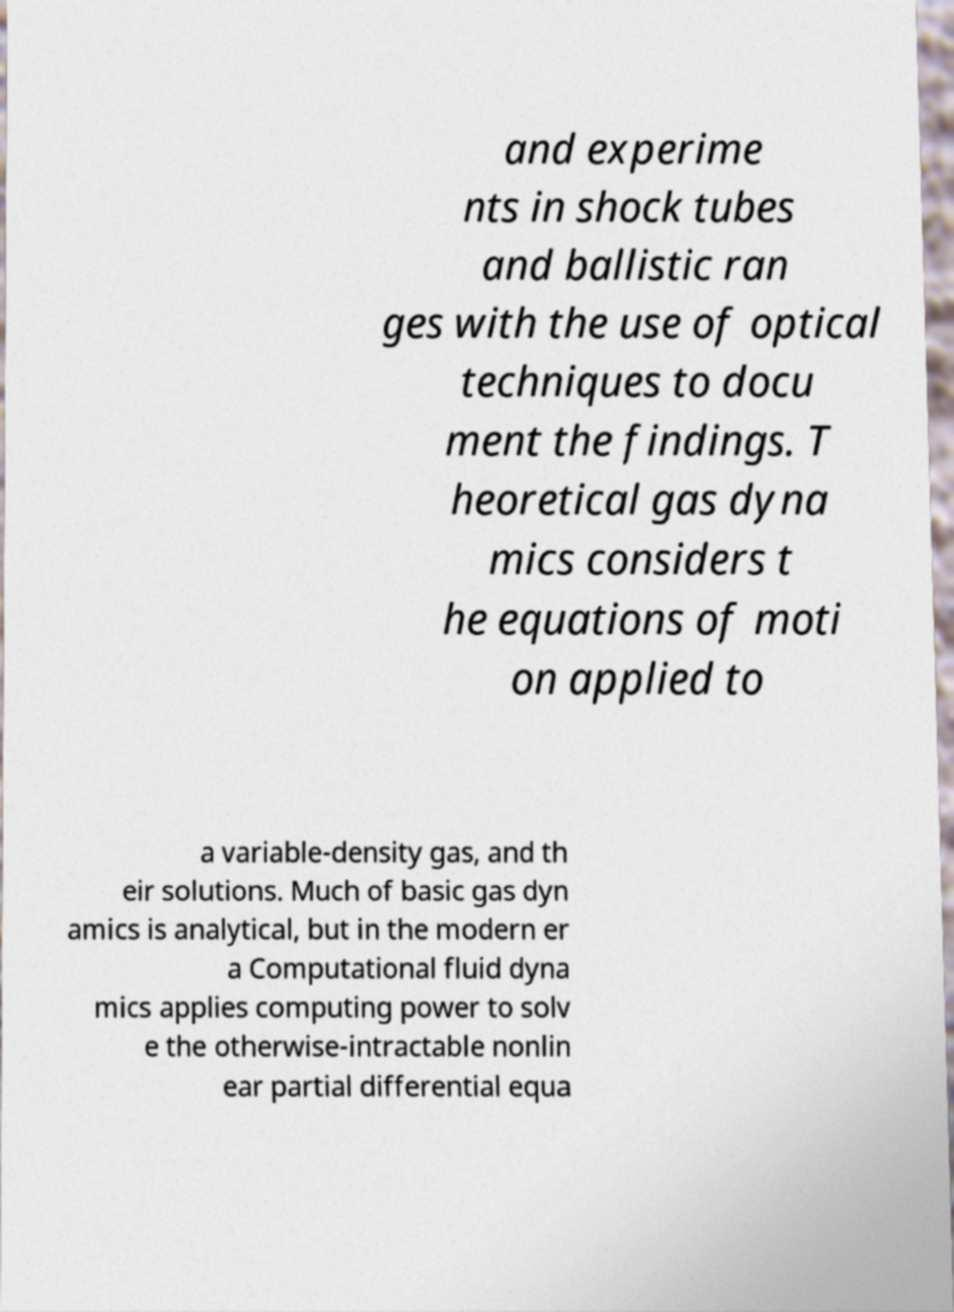Can you accurately transcribe the text from the provided image for me? and experime nts in shock tubes and ballistic ran ges with the use of optical techniques to docu ment the findings. T heoretical gas dyna mics considers t he equations of moti on applied to a variable-density gas, and th eir solutions. Much of basic gas dyn amics is analytical, but in the modern er a Computational fluid dyna mics applies computing power to solv e the otherwise-intractable nonlin ear partial differential equa 